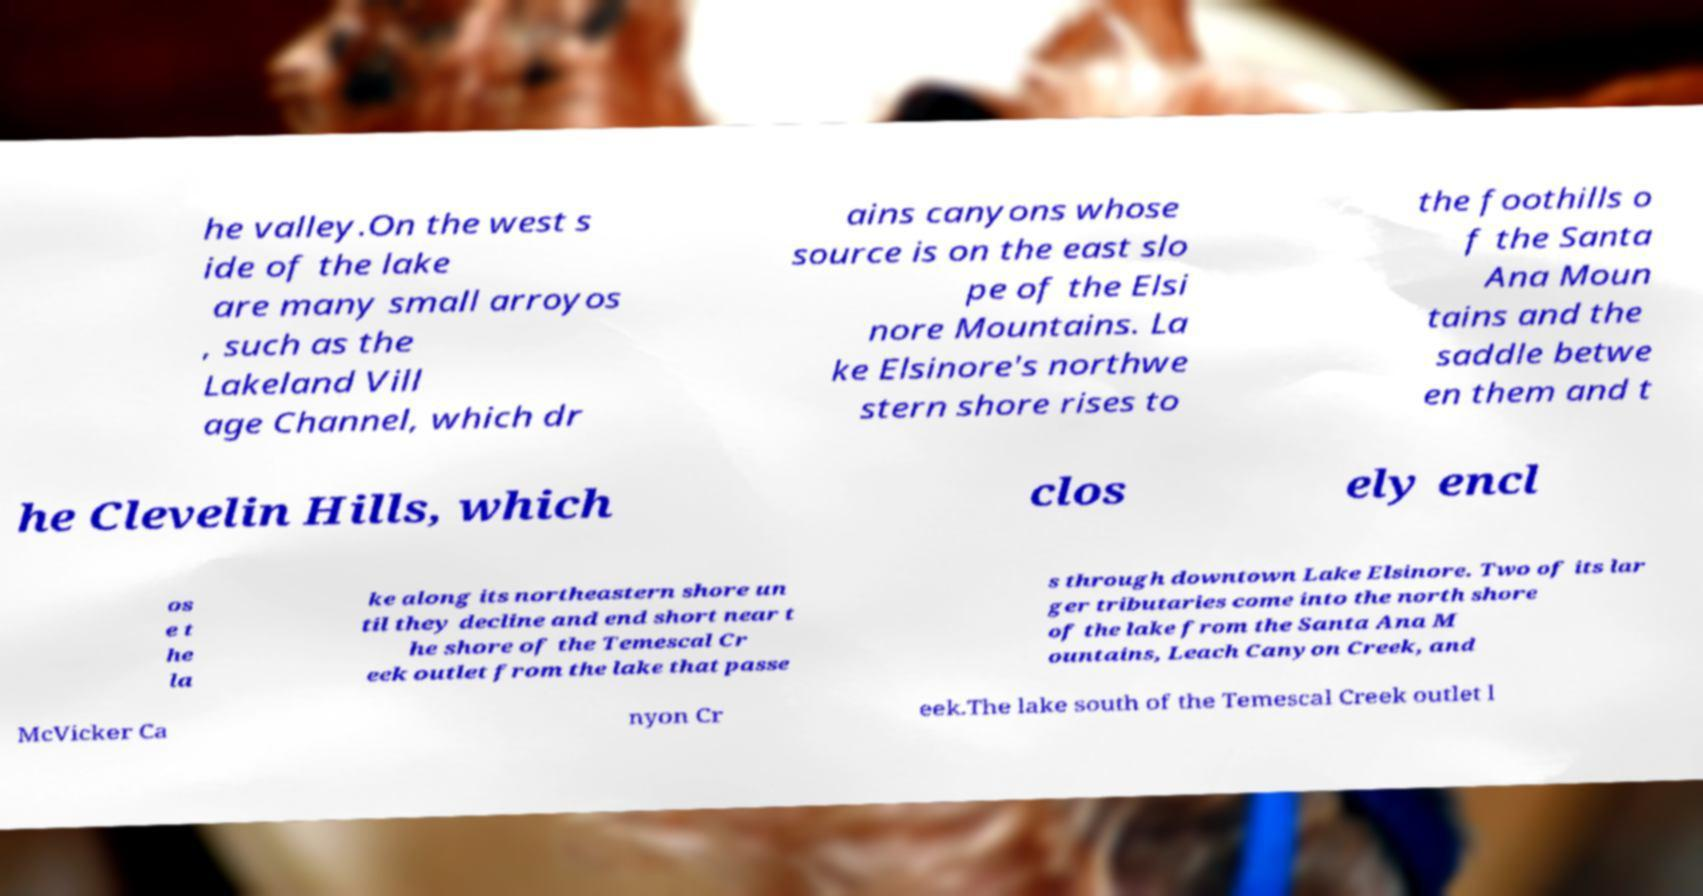Could you assist in decoding the text presented in this image and type it out clearly? he valley.On the west s ide of the lake are many small arroyos , such as the Lakeland Vill age Channel, which dr ains canyons whose source is on the east slo pe of the Elsi nore Mountains. La ke Elsinore's northwe stern shore rises to the foothills o f the Santa Ana Moun tains and the saddle betwe en them and t he Clevelin Hills, which clos ely encl os e t he la ke along its northeastern shore un til they decline and end short near t he shore of the Temescal Cr eek outlet from the lake that passe s through downtown Lake Elsinore. Two of its lar ger tributaries come into the north shore of the lake from the Santa Ana M ountains, Leach Canyon Creek, and McVicker Ca nyon Cr eek.The lake south of the Temescal Creek outlet l 